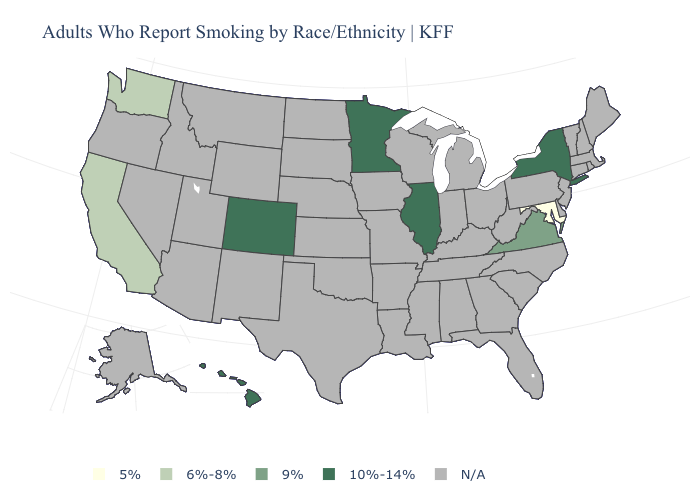Name the states that have a value in the range 5%?
Answer briefly. Maryland. Does the first symbol in the legend represent the smallest category?
Be succinct. Yes. Name the states that have a value in the range N/A?
Answer briefly. Alabama, Alaska, Arizona, Arkansas, Connecticut, Delaware, Florida, Georgia, Idaho, Indiana, Iowa, Kansas, Kentucky, Louisiana, Maine, Massachusetts, Michigan, Mississippi, Missouri, Montana, Nebraska, Nevada, New Hampshire, New Jersey, New Mexico, North Carolina, North Dakota, Ohio, Oklahoma, Oregon, Pennsylvania, Rhode Island, South Carolina, South Dakota, Tennessee, Texas, Utah, Vermont, West Virginia, Wisconsin, Wyoming. Name the states that have a value in the range N/A?
Be succinct. Alabama, Alaska, Arizona, Arkansas, Connecticut, Delaware, Florida, Georgia, Idaho, Indiana, Iowa, Kansas, Kentucky, Louisiana, Maine, Massachusetts, Michigan, Mississippi, Missouri, Montana, Nebraska, Nevada, New Hampshire, New Jersey, New Mexico, North Carolina, North Dakota, Ohio, Oklahoma, Oregon, Pennsylvania, Rhode Island, South Carolina, South Dakota, Tennessee, Texas, Utah, Vermont, West Virginia, Wisconsin, Wyoming. What is the value of Louisiana?
Concise answer only. N/A. Name the states that have a value in the range N/A?
Give a very brief answer. Alabama, Alaska, Arizona, Arkansas, Connecticut, Delaware, Florida, Georgia, Idaho, Indiana, Iowa, Kansas, Kentucky, Louisiana, Maine, Massachusetts, Michigan, Mississippi, Missouri, Montana, Nebraska, Nevada, New Hampshire, New Jersey, New Mexico, North Carolina, North Dakota, Ohio, Oklahoma, Oregon, Pennsylvania, Rhode Island, South Carolina, South Dakota, Tennessee, Texas, Utah, Vermont, West Virginia, Wisconsin, Wyoming. Does the map have missing data?
Short answer required. Yes. How many symbols are there in the legend?
Give a very brief answer. 5. What is the value of Kansas?
Quick response, please. N/A. Is the legend a continuous bar?
Give a very brief answer. No. Does the first symbol in the legend represent the smallest category?
Keep it brief. Yes. What is the value of Utah?
Quick response, please. N/A. 